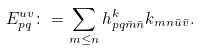<formula> <loc_0><loc_0><loc_500><loc_500>E _ { p q } ^ { u v } \colon = \sum _ { m \leq n } h ^ { k } _ { p q \bar { m } \bar { n } } k _ { m n \bar { u } \bar { v } } .</formula> 